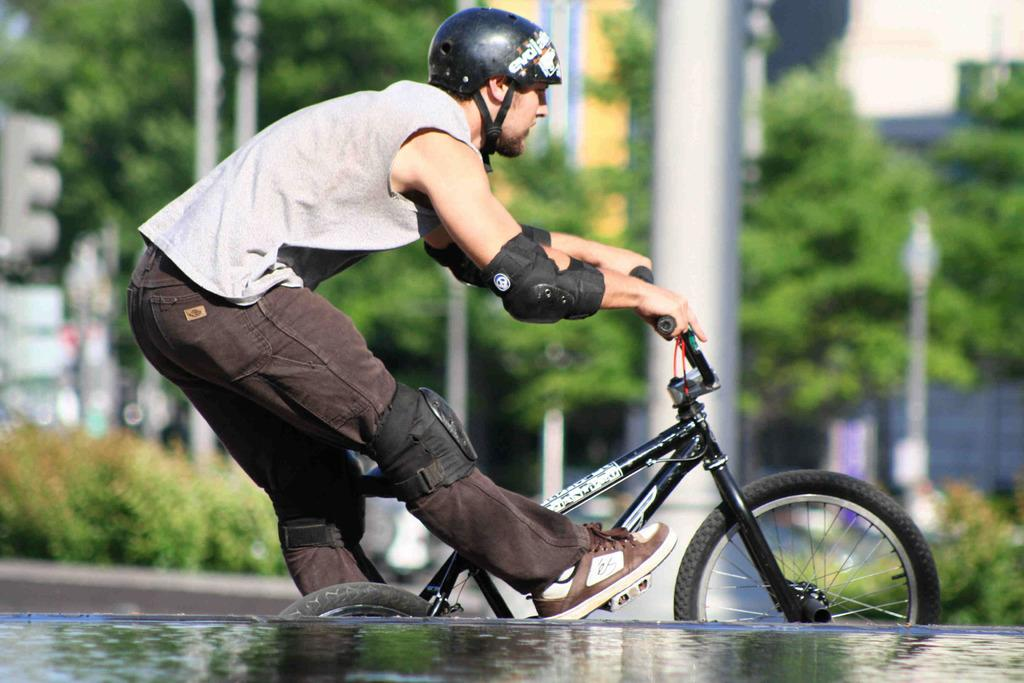What is the person in the image doing? There is a person riding a bicycle in the image. What safety precaution is the person taking while riding the bicycle? The person is wearing a helmet. What can be seen in the background of the image? There are trees and poles in the background of the image. What is visible at the bottom of the image? There is water visible at the bottom of the image. What type of lumber is being discussed by the trees in the background of the image? There is no discussion or lumber present in the image; it features a person riding a bicycle with trees and poles in the background. 